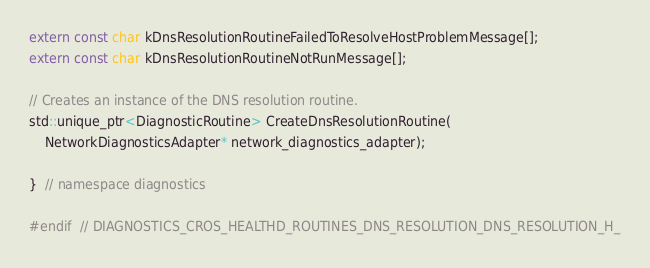Convert code to text. <code><loc_0><loc_0><loc_500><loc_500><_C_>extern const char kDnsResolutionRoutineFailedToResolveHostProblemMessage[];
extern const char kDnsResolutionRoutineNotRunMessage[];

// Creates an instance of the DNS resolution routine.
std::unique_ptr<DiagnosticRoutine> CreateDnsResolutionRoutine(
    NetworkDiagnosticsAdapter* network_diagnostics_adapter);

}  // namespace diagnostics

#endif  // DIAGNOSTICS_CROS_HEALTHD_ROUTINES_DNS_RESOLUTION_DNS_RESOLUTION_H_
</code> 